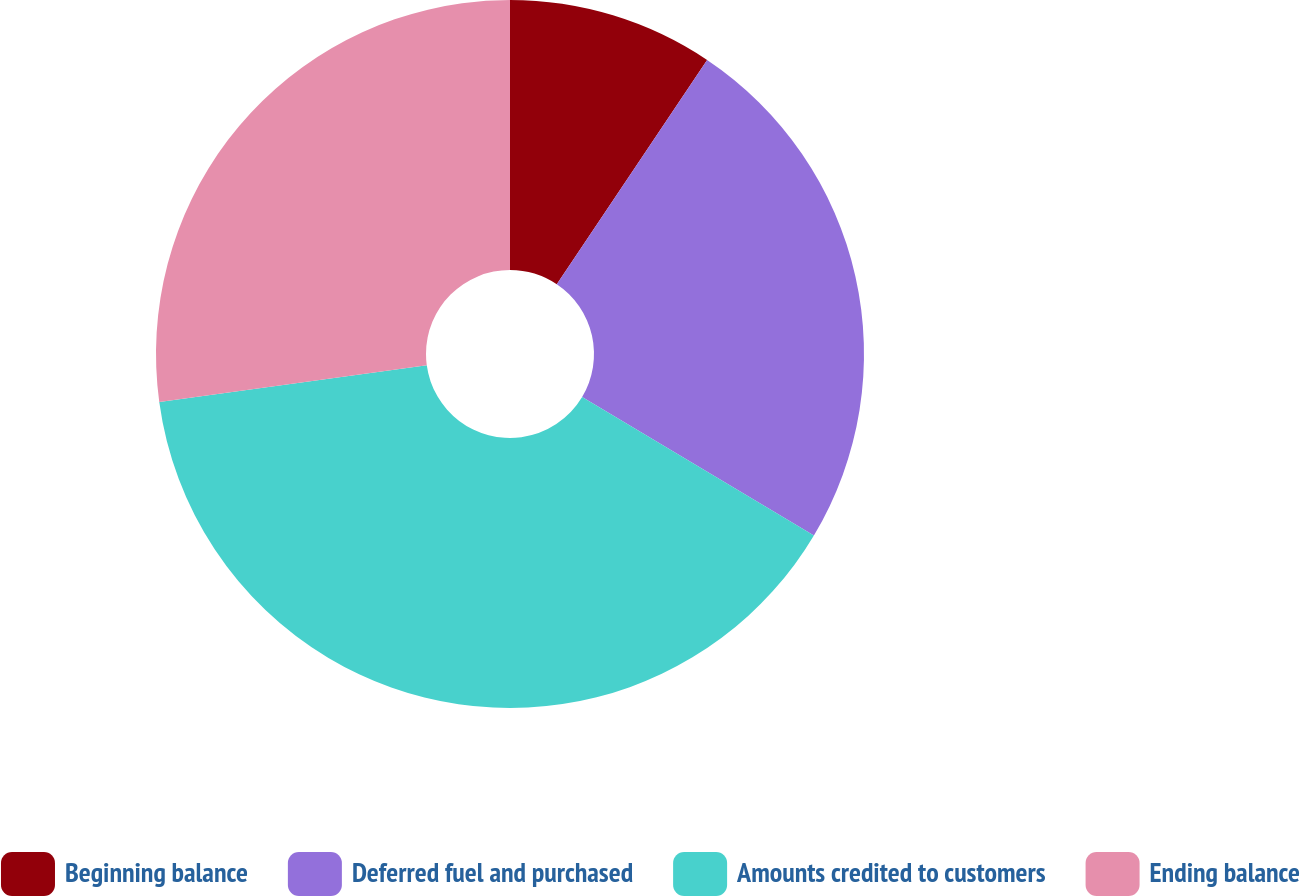Convert chart to OTSL. <chart><loc_0><loc_0><loc_500><loc_500><pie_chart><fcel>Beginning balance<fcel>Deferred fuel and purchased<fcel>Amounts credited to customers<fcel>Ending balance<nl><fcel>9.4%<fcel>24.17%<fcel>39.27%<fcel>27.16%<nl></chart> 